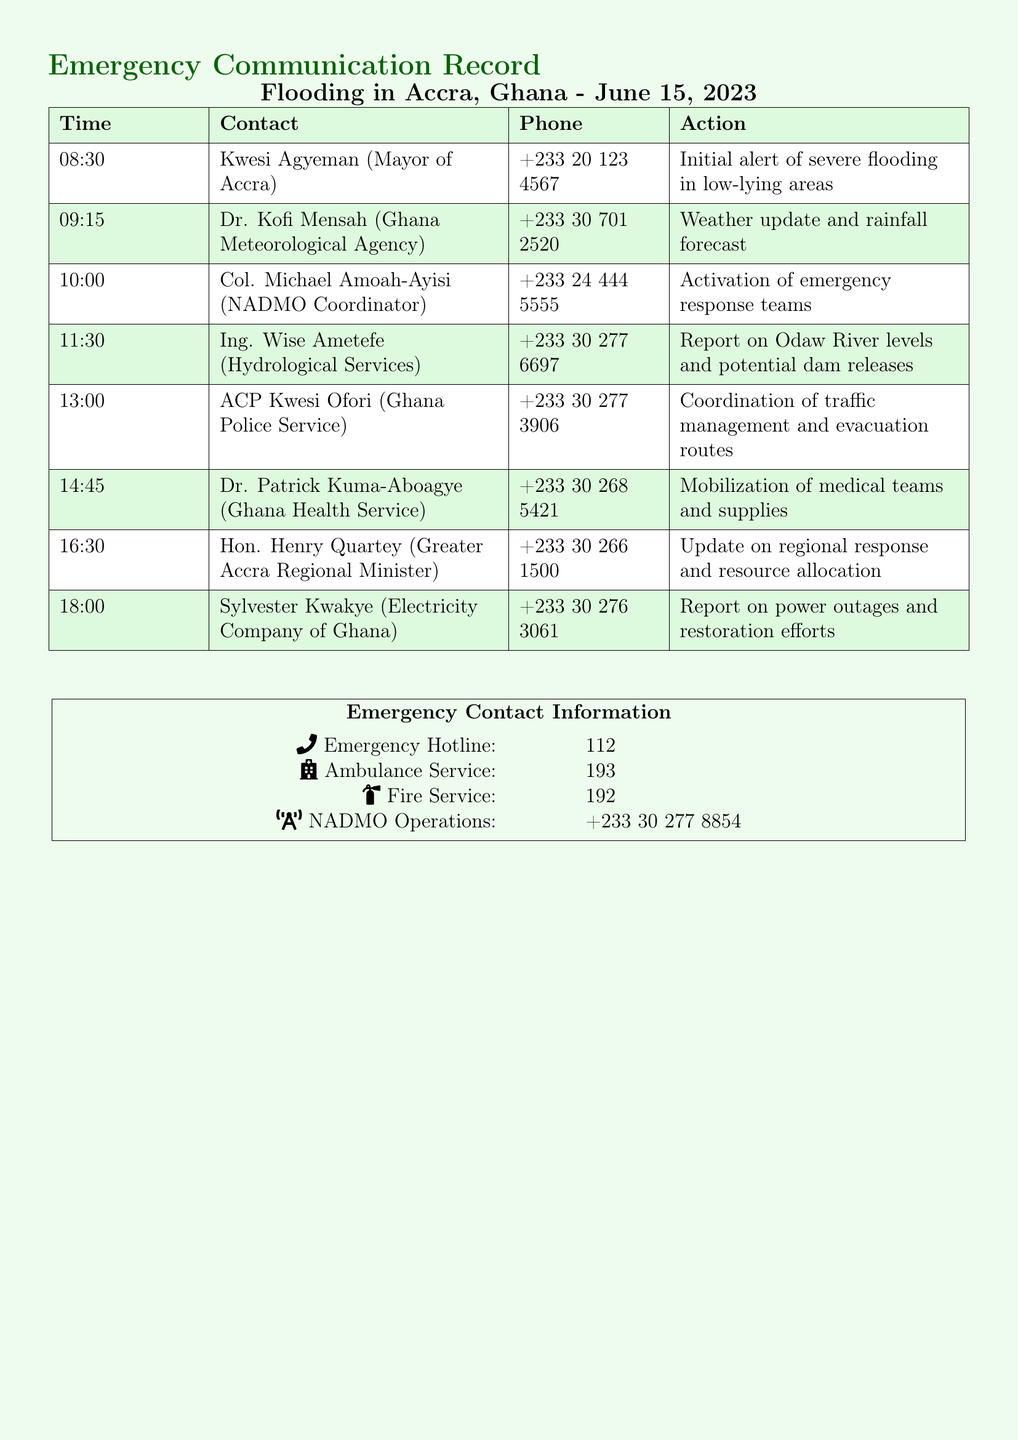What time did Kwesi Agyeman make the initial alert? The time of the initial alert from Kwesi Agyeman is recorded in the document as 08:30.
Answer: 08:30 Who is the NADMO Coordinator? The document lists Col. Michael Amoah-Ayisi as the NADMO Coordinator.
Answer: Col. Michael Amoah-Ayisi What is the contact number for the Police Service? The document specifies the contact number for the Ghana Police Service, which is +233 30 277 3906.
Answer: +233 30 277 3906 At what time was the update on regional response provided? The update on regional response was given by Hon. Henry Quartey at 16:30.
Answer: 16:30 Which agency provided a weather update? The weather update was provided by Dr. Kofi Mensah from the Ghana Meteorological Agency.
Answer: Dr. Kofi Mensah What action was taken at 13:00? At 13:00, the action taken was the coordination of traffic management and evacuation routes.
Answer: Coordination of traffic management and evacuation routes How many key contacts are listed in the document? The document lists a total of seven key contacts.
Answer: Seven What emergency hotline number is provided? The document provides the emergency hotline number as 112.
Answer: 112 What service does the number 193 belong to? The number 193 in the document corresponds to the Ambulance Service.
Answer: Ambulance Service 